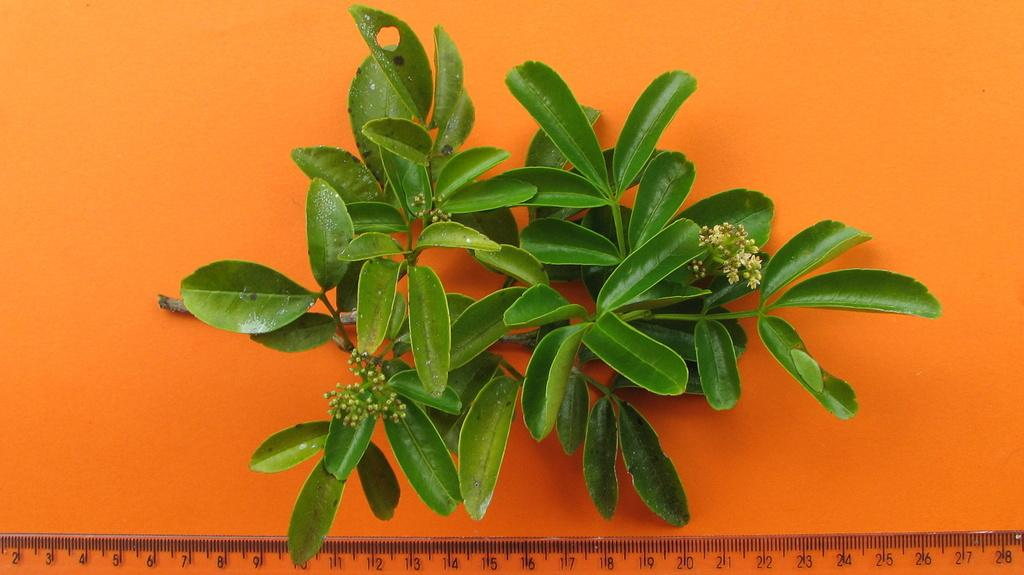What type of object can be seen in the image? There is a plant in the image. What other object is present in the image? There is a scale in the image. What color is the background of the image? The background of the image is orange in color. How many stitches are visible on the plant in the image? There are no stitches present on the plant in the image, as stitches are typically associated with fabric or sewing and not plants. 